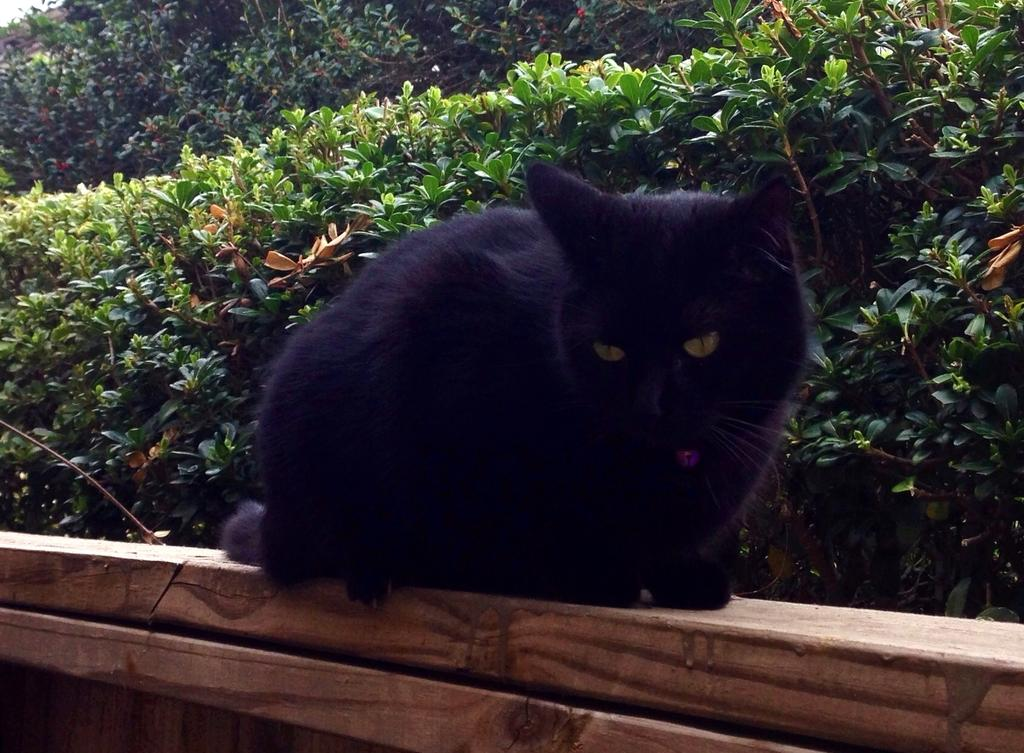What animal is present in the image? There is a cat in the image. Where is the cat located? The cat is on a wooden fence. What can be seen in the background of the image? There are trees in the background of the image. What type of patch is the cat wearing in the image? There is no patch visible on the cat in the image. 